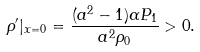<formula> <loc_0><loc_0><loc_500><loc_500>\rho ^ { \prime } | _ { x = 0 } = \frac { ( a ^ { 2 } - 1 ) \alpha P _ { 1 } } { a ^ { 2 } \rho _ { 0 } } > 0 .</formula> 